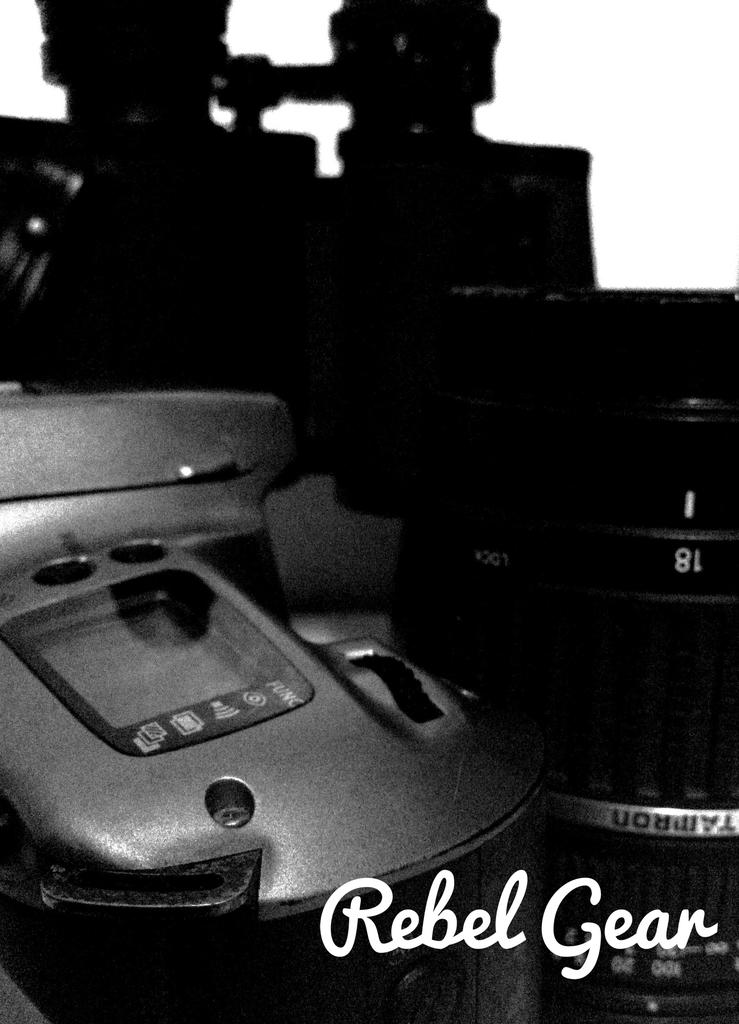What objects are present in the image? There are camera parts in the image. What color is the background of the image? The background of the image is white. What type of nail is being hammered into the sky in the image? There is no nail or sky present in the image; it only features camera parts and a white background. 